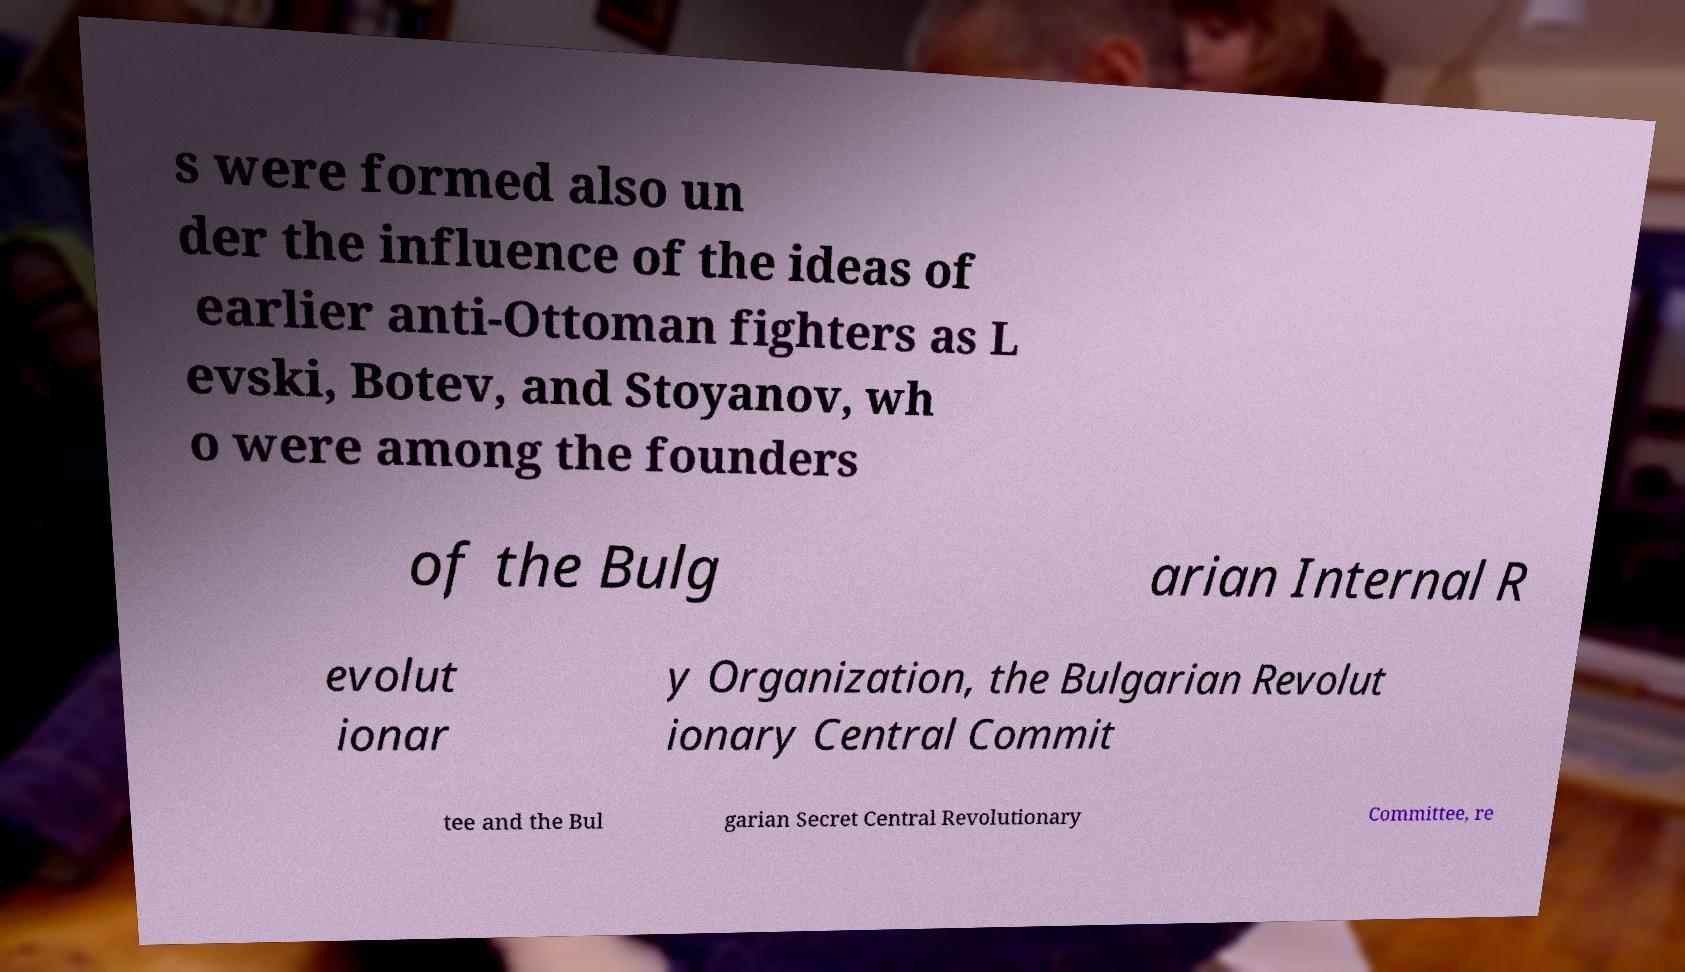Please identify and transcribe the text found in this image. s were formed also un der the influence of the ideas of earlier anti-Ottoman fighters as L evski, Botev, and Stoyanov, wh o were among the founders of the Bulg arian Internal R evolut ionar y Organization, the Bulgarian Revolut ionary Central Commit tee and the Bul garian Secret Central Revolutionary Committee, re 